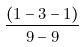<formula> <loc_0><loc_0><loc_500><loc_500>\frac { ( 1 - 3 - 1 ) } { 9 - 9 }</formula> 